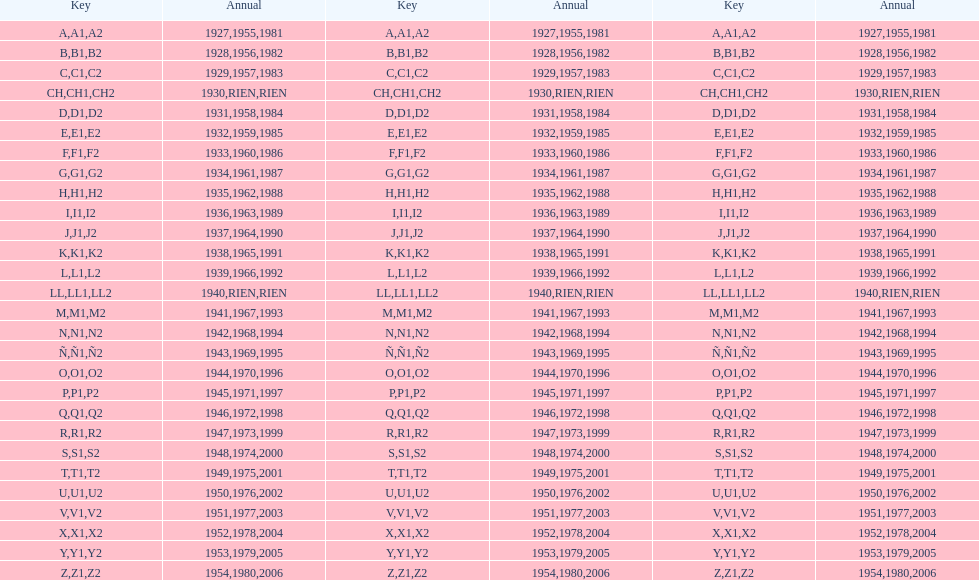Other than 1927 what year did the code start with a? 1955, 1981. Write the full table. {'header': ['Key', 'Annual', 'Key', 'Annual', 'Key', 'Annual'], 'rows': [['A', '1927', 'A1', '1955', 'A2', '1981'], ['B', '1928', 'B1', '1956', 'B2', '1982'], ['C', '1929', 'C1', '1957', 'C2', '1983'], ['CH', '1930', 'CH1', 'RIEN', 'CH2', 'RIEN'], ['D', '1931', 'D1', '1958', 'D2', '1984'], ['E', '1932', 'E1', '1959', 'E2', '1985'], ['F', '1933', 'F1', '1960', 'F2', '1986'], ['G', '1934', 'G1', '1961', 'G2', '1987'], ['H', '1935', 'H1', '1962', 'H2', '1988'], ['I', '1936', 'I1', '1963', 'I2', '1989'], ['J', '1937', 'J1', '1964', 'J2', '1990'], ['K', '1938', 'K1', '1965', 'K2', '1991'], ['L', '1939', 'L1', '1966', 'L2', '1992'], ['LL', '1940', 'LL1', 'RIEN', 'LL2', 'RIEN'], ['M', '1941', 'M1', '1967', 'M2', '1993'], ['N', '1942', 'N1', '1968', 'N2', '1994'], ['Ñ', '1943', 'Ñ1', '1969', 'Ñ2', '1995'], ['O', '1944', 'O1', '1970', 'O2', '1996'], ['P', '1945', 'P1', '1971', 'P2', '1997'], ['Q', '1946', 'Q1', '1972', 'Q2', '1998'], ['R', '1947', 'R1', '1973', 'R2', '1999'], ['S', '1948', 'S1', '1974', 'S2', '2000'], ['T', '1949', 'T1', '1975', 'T2', '2001'], ['U', '1950', 'U1', '1976', 'U2', '2002'], ['V', '1951', 'V1', '1977', 'V2', '2003'], ['X', '1952', 'X1', '1978', 'X2', '2004'], ['Y', '1953', 'Y1', '1979', 'Y2', '2005'], ['Z', '1954', 'Z1', '1980', 'Z2', '2006']]} 